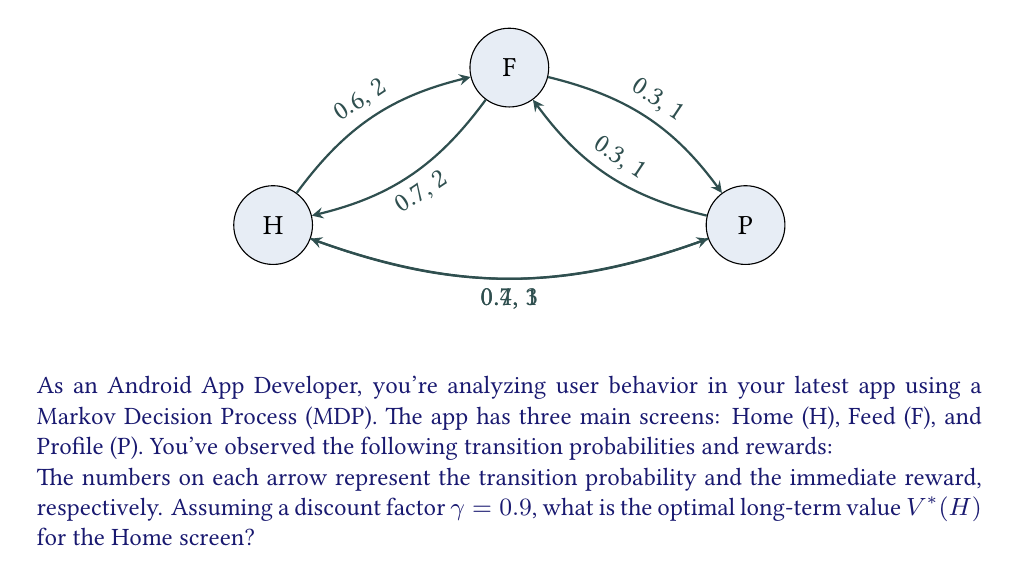Can you solve this math problem? To solve this problem, we'll use the Bellman optimality equation for MDPs:

$$V^*(s) = \max_a \sum_{s'} P(s'|s,a)[R(s,a,s') + \gamma V^*(s')]$$

Where:
- $V^*(s)$ is the optimal value function for state $s$
- $P(s'|s,a)$ is the transition probability from state $s$ to $s'$ given action $a$
- $R(s,a,s')$ is the immediate reward for transitioning from $s$ to $s'$ with action $a$
- $\gamma$ is the discount factor

We'll set up equations for each state:

1) For Home (H):
   $$V^*(H) = \max\{0.6[2 + 0.9V^*(F)] + 0.4[1 + 0.9V^*(P)],\; 1[3 + 0.9V^*(P)]\}$$

2) For Feed (F):
   $$V^*(F) = \max\{0.7[2 + 0.9V^*(H)] + 0.3[1 + 0.9V^*(P)]\}$$

3) For Profile (P):
   $$V^*(P) = \max\{0.7[3 + 0.9V^*(H)] + 0.3[1 + 0.9V^*(F)]\}$$

We can solve this system of equations iteratively:

Step 1: Initialize $V^*(H) = V^*(F) = V^*(P) = 0$

Step 2: Update values:
$V^*(H) = \max\{0.6[2 + 0.9(0)] + 0.4[1 + 0.9(0)],\; 1[3 + 0.9(0)]\} = \max\{1.6,\; 3\} = 3$
$V^*(F) = 0.7[2 + 0.9(3)] + 0.3[1 + 0.9(0)] = 3.19$
$V^*(P) = 0.7[3 + 0.9(3)] + 0.3[1 + 0.9(3.19)] = 4.77$

Step 3: Repeat until convergence:
$V^*(H) = \max\{0.6[2 + 0.9(3.19)] + 0.4[1 + 0.9(4.77)],\; 1[3 + 0.9(4.77)]\} = \max\{4.22,\; 7.29\} = 7.29$
$V^*(F) = 0.7[2 + 0.9(7.29)] + 0.3[1 + 0.9(4.77)] = 6.39$
$V^*(P) = 0.7[3 + 0.9(7.29)] + 0.3[1 + 0.9(6.39)] = 8.22$

After several iterations, the values converge to:
$V^*(H) \approx 9.76$
$V^*(F) \approx 8.78$
$V^*(P) \approx 10.60$

Therefore, the optimal long-term value for the Home screen, $V^*(H)$, is approximately 9.76.
Answer: 9.76 